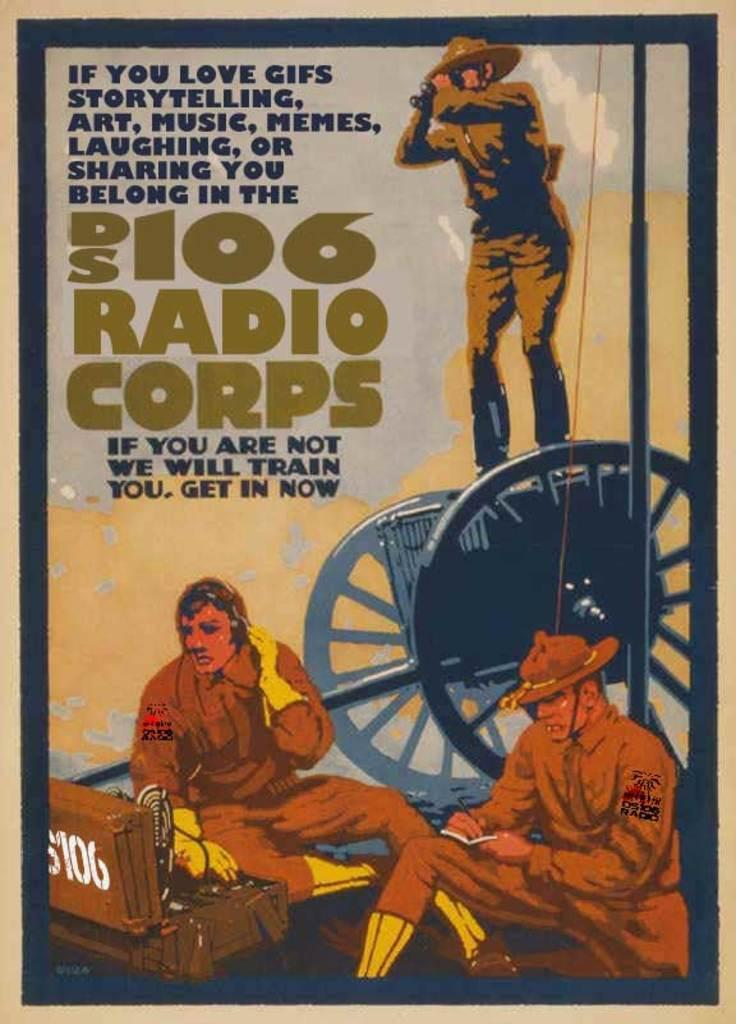<image>
Create a compact narrative representing the image presented. Poster showing three men and the words "Radio Corps". 